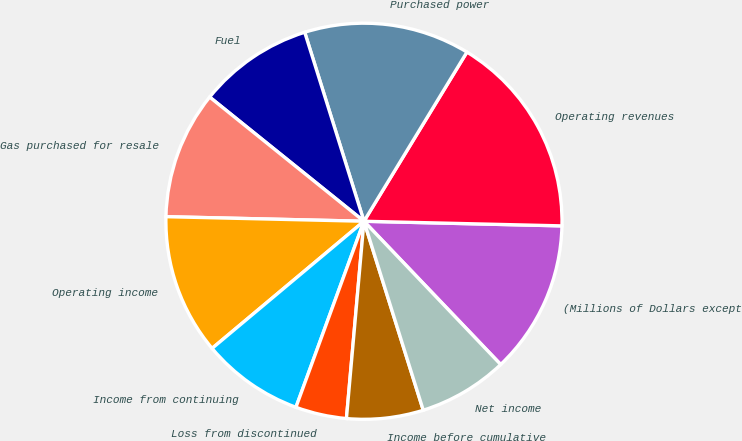Convert chart to OTSL. <chart><loc_0><loc_0><loc_500><loc_500><pie_chart><fcel>(Millions of Dollars except<fcel>Operating revenues<fcel>Purchased power<fcel>Fuel<fcel>Gas purchased for resale<fcel>Operating income<fcel>Income from continuing<fcel>Loss from discontinued<fcel>Income before cumulative<fcel>Net income<nl><fcel>12.5%<fcel>16.67%<fcel>13.54%<fcel>9.38%<fcel>10.42%<fcel>11.46%<fcel>8.33%<fcel>4.17%<fcel>6.25%<fcel>7.29%<nl></chart> 